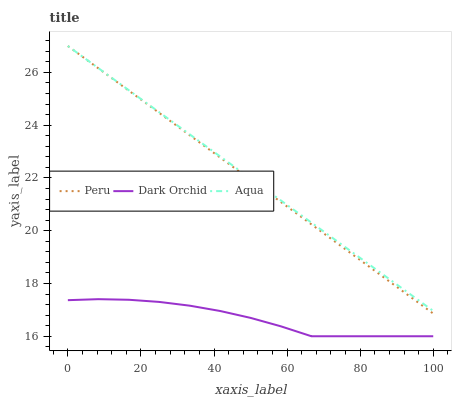Does Dark Orchid have the minimum area under the curve?
Answer yes or no. Yes. Does Aqua have the maximum area under the curve?
Answer yes or no. Yes. Does Peru have the minimum area under the curve?
Answer yes or no. No. Does Peru have the maximum area under the curve?
Answer yes or no. No. Is Peru the smoothest?
Answer yes or no. Yes. Is Dark Orchid the roughest?
Answer yes or no. Yes. Is Dark Orchid the smoothest?
Answer yes or no. No. Is Peru the roughest?
Answer yes or no. No. Does Dark Orchid have the lowest value?
Answer yes or no. Yes. Does Peru have the lowest value?
Answer yes or no. No. Does Peru have the highest value?
Answer yes or no. Yes. Does Dark Orchid have the highest value?
Answer yes or no. No. Is Dark Orchid less than Peru?
Answer yes or no. Yes. Is Peru greater than Dark Orchid?
Answer yes or no. Yes. Does Aqua intersect Peru?
Answer yes or no. Yes. Is Aqua less than Peru?
Answer yes or no. No. Is Aqua greater than Peru?
Answer yes or no. No. Does Dark Orchid intersect Peru?
Answer yes or no. No. 